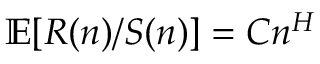<formula> <loc_0><loc_0><loc_500><loc_500>\mathbb { E } [ R ( n ) / S ( n ) ] = C n ^ { H }</formula> 